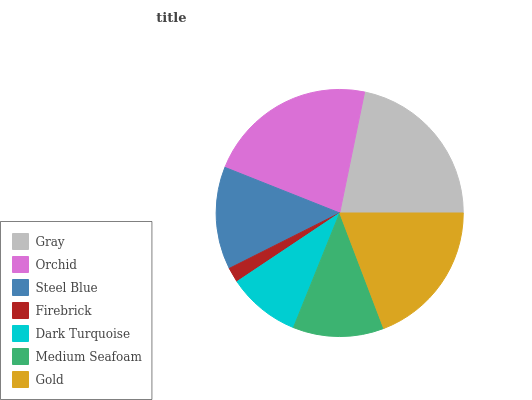Is Firebrick the minimum?
Answer yes or no. Yes. Is Orchid the maximum?
Answer yes or no. Yes. Is Steel Blue the minimum?
Answer yes or no. No. Is Steel Blue the maximum?
Answer yes or no. No. Is Orchid greater than Steel Blue?
Answer yes or no. Yes. Is Steel Blue less than Orchid?
Answer yes or no. Yes. Is Steel Blue greater than Orchid?
Answer yes or no. No. Is Orchid less than Steel Blue?
Answer yes or no. No. Is Steel Blue the high median?
Answer yes or no. Yes. Is Steel Blue the low median?
Answer yes or no. Yes. Is Gray the high median?
Answer yes or no. No. Is Gold the low median?
Answer yes or no. No. 